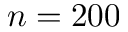<formula> <loc_0><loc_0><loc_500><loc_500>n = 2 0 0</formula> 